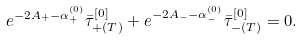Convert formula to latex. <formula><loc_0><loc_0><loc_500><loc_500>e ^ { - 2 A _ { + } - \alpha ^ { ( 0 ) } _ { + } } \bar { \tau } _ { + ( T ) } ^ { [ 0 ] } + e ^ { - 2 A _ { - } - \alpha ^ { ( 0 ) } _ { - } } \bar { \tau } _ { - ( T ) } ^ { [ 0 ] } = 0 .</formula> 